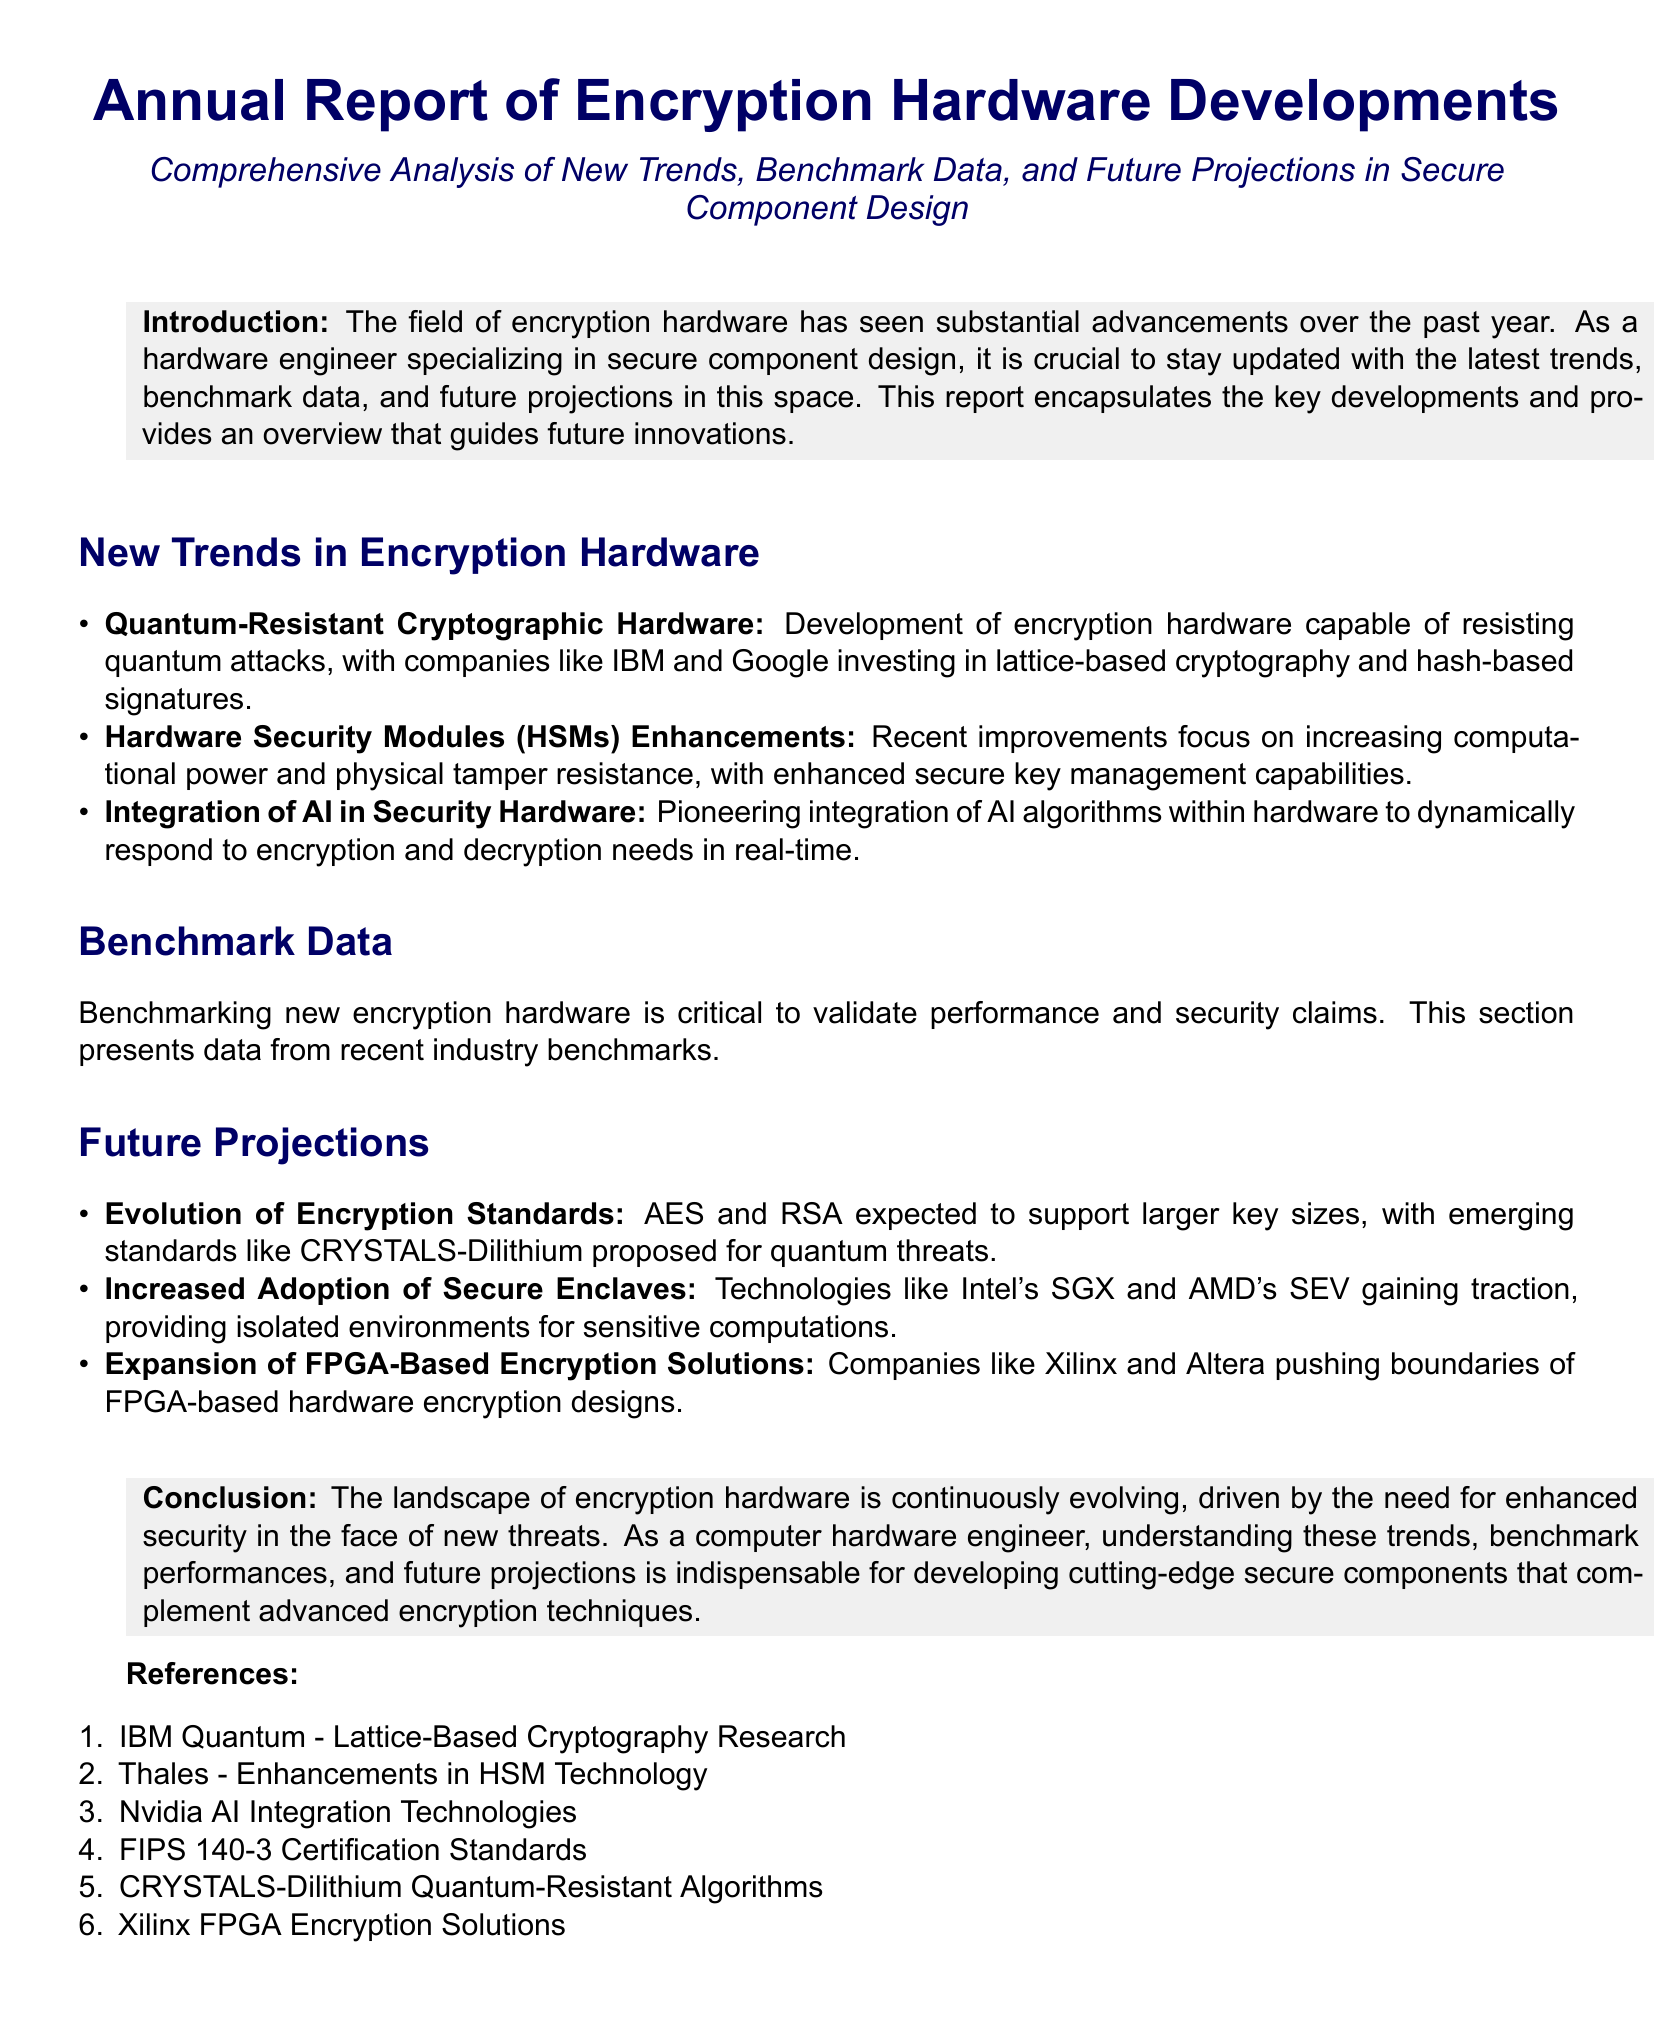What is the main focus of this report? The report focuses on advancements in the field of encryption hardware, exploring trends, benchmark data, and future projections important for secure component design.
Answer: Advancements in encryption hardware Which companies are investing in quantum-resistant cryptography? IBM and Google are noted in the document for their investments in lattice-based cryptography and hash-based signatures.
Answer: IBM and Google What is an example of a technology gaining traction for secure computations? Technologies such as Intel's SGX and AMD's SEV are highlighted for providing isolated environments for sensitive computations.
Answer: Intel's SGX and AMD's SEV How are AI algorithms being utilized within security hardware? The document describes a pioneering integration of AI algorithms within hardware to respond to encryption and decryption needs in real-time.
Answer: Real-time response What is one of the future projections regarding encryption standards? The report mentions that AES and RSA are expected to support larger key sizes, with emerging standards proposed for quantum threats.
Answer: Support larger key sizes What type of hardware has seen improvements in computational power and tamper resistance? Hardware Security Modules (HSMs) have enhanced capabilities in both computational power and physical tamper resistance.
Answer: Hardware Security Modules (HSMs) What is the significance of benchmarking new encryption hardware? Benchmarking is crucial to validate performance and security claims of new encryption hardware in the industry.
Answer: Validate performance and security claims What emerging standard is proposed for quantum threats? The report references CRYSTALS-Dilithium as an emerging standard proposed to address quantum threats.
Answer: CRYSTALS-Dilithium 